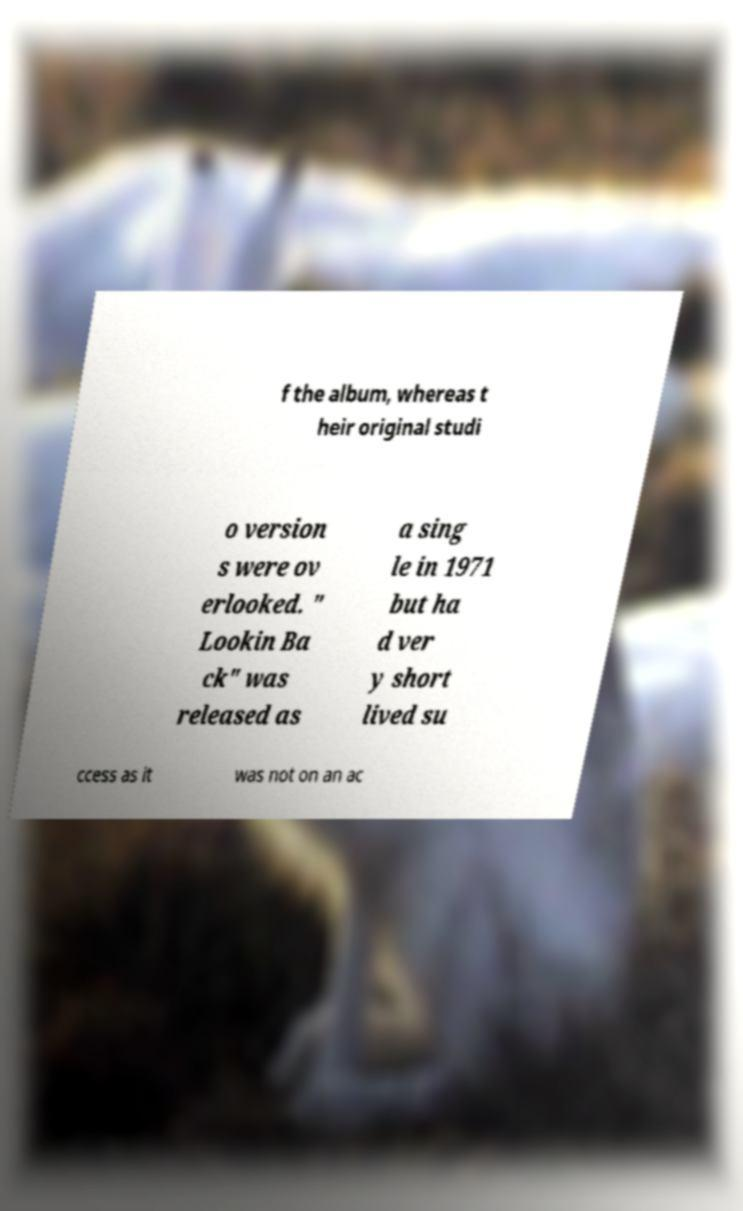Please identify and transcribe the text found in this image. f the album, whereas t heir original studi o version s were ov erlooked. " Lookin Ba ck" was released as a sing le in 1971 but ha d ver y short lived su ccess as it was not on an ac 